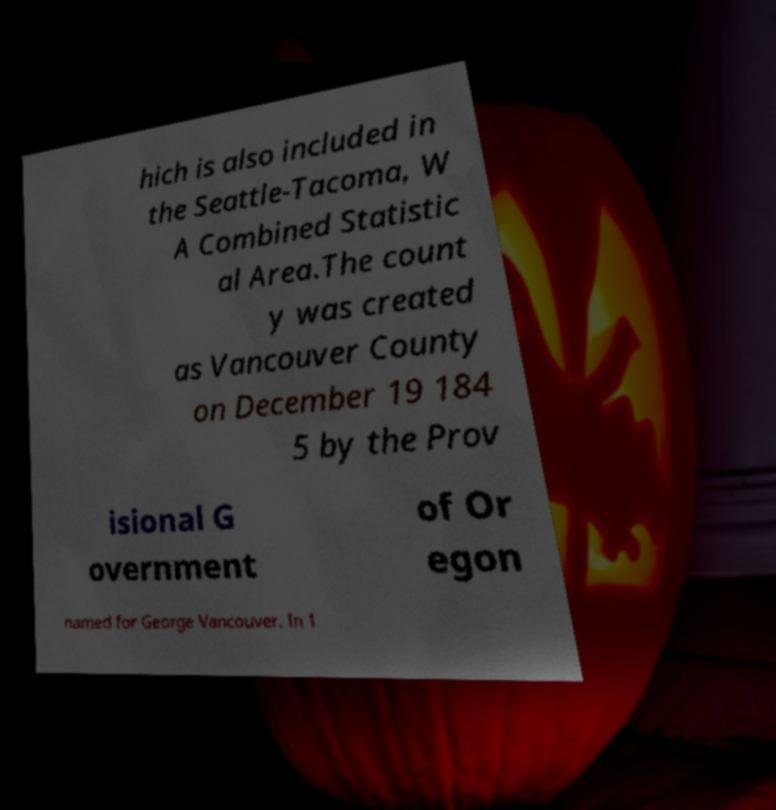Please identify and transcribe the text found in this image. hich is also included in the Seattle-Tacoma, W A Combined Statistic al Area.The count y was created as Vancouver County on December 19 184 5 by the Prov isional G overnment of Or egon named for George Vancouver. In 1 